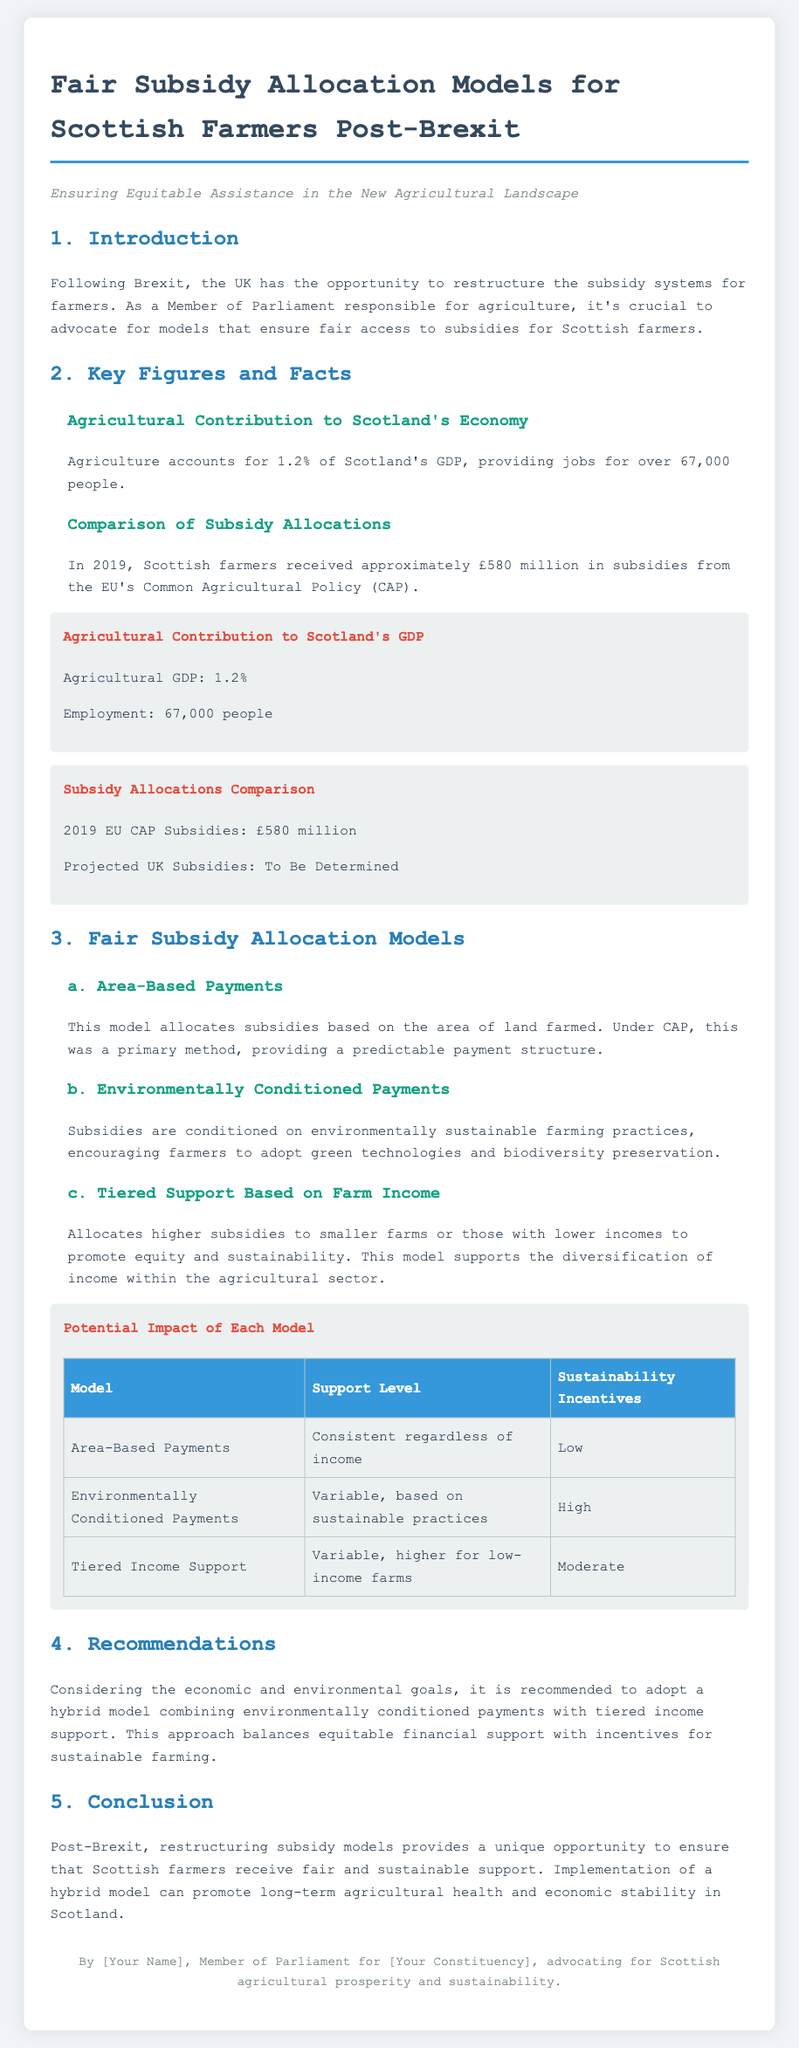What percentage of Scotland's GDP does agriculture account for? The document states that agriculture accounts for 1.2% of Scotland's GDP.
Answer: 1.2% How many jobs does agriculture provide in Scotland? The document mentions that agriculture provides jobs for over 67,000 people.
Answer: 67,000 What were the 2019 EU CAP subsidies for Scottish farmers? According to the document, Scottish farmers received approximately £580 million in subsidies from the EU's Common Agricultural Policy in 2019.
Answer: £580 million What is the recommended subsidy model for Scottish farmers? The document recommends adopting a hybrid model combining environmentally conditioned payments with tiered income support.
Answer: Hybrid model What is the support level for area-based payments? The document specifies that area-based payments provide consistent support regardless of income.
Answer: Consistent regardless of income Which subsidy model has high sustainability incentives? The document states that environmentally conditioned payments have high sustainability incentives.
Answer: Environmentally Conditioned Payments What is the projected subsidy amount for the UK? The document indicates that the projected UK subsidies are "To Be Determined."
Answer: To Be Determined What is the impact of tiered income support on low-income farms? The document explains that tiered income support allocates higher subsidies to smaller farms or those with lower incomes.
Answer: Higher subsidies 